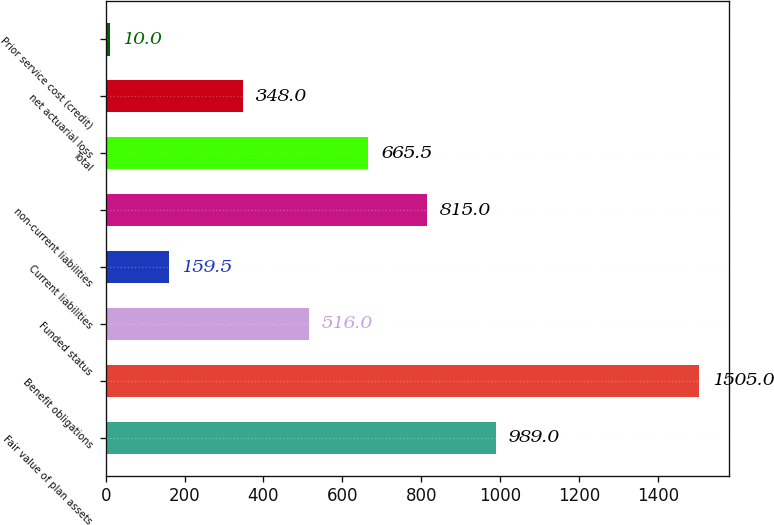<chart> <loc_0><loc_0><loc_500><loc_500><bar_chart><fcel>Fair value of plan assets<fcel>Benefit obligations<fcel>Funded status<fcel>Current liabilities<fcel>non-current liabilities<fcel>Total<fcel>net actuarial loss<fcel>Prior service cost (credit)<nl><fcel>989<fcel>1505<fcel>516<fcel>159.5<fcel>815<fcel>665.5<fcel>348<fcel>10<nl></chart> 